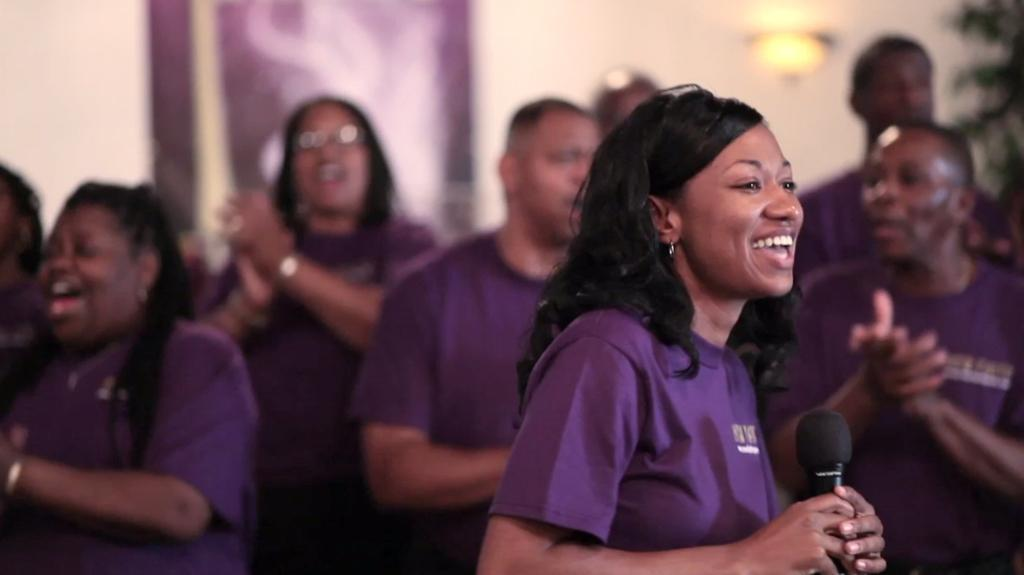What can be seen in the image involving multiple individuals? There are groups of people in the image. Can you describe the woman in the image? The woman in the image is smiling and holding a microphone. What is visible in the background of the image? There is a wall and a light in the background of the image. What type of stew is being served to the groups of people in the image? There is no stew present in the image; it features groups of people and a woman holding a microphone. Can you see any grass in the image? There is no grass visible in the image. 